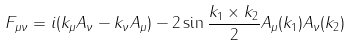Convert formula to latex. <formula><loc_0><loc_0><loc_500><loc_500>F _ { \mu \nu } = i ( k _ { \mu } A _ { \nu } - k _ { \nu } A _ { \mu } ) - 2 \sin \frac { k _ { 1 } \times k _ { 2 } } { 2 } A _ { \mu } ( k _ { 1 } ) A _ { \nu } ( k _ { 2 } )</formula> 